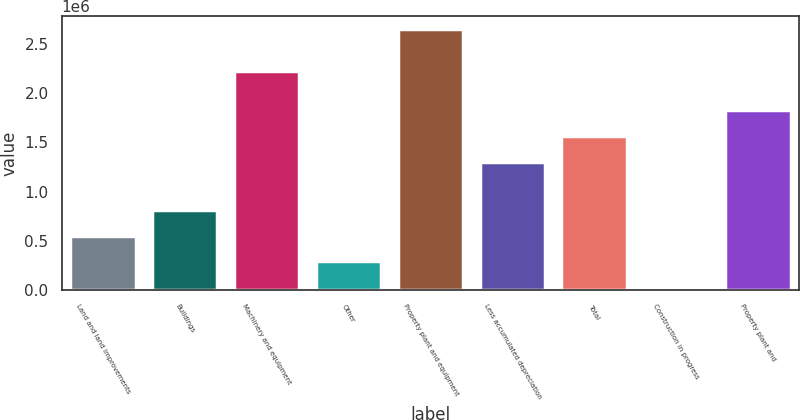Convert chart. <chart><loc_0><loc_0><loc_500><loc_500><bar_chart><fcel>Land and land improvements<fcel>Buildings<fcel>Machinery and equipment<fcel>Other<fcel>Property plant and equipment<fcel>Less accumulated depreciation<fcel>Total<fcel>Construction in progress<fcel>Property plant and<nl><fcel>553876<fcel>815000<fcel>2.21946e+06<fcel>292753<fcel>2.64286e+06<fcel>1.30167e+06<fcel>1.56279e+06<fcel>31630<fcel>1.82392e+06<nl></chart> 